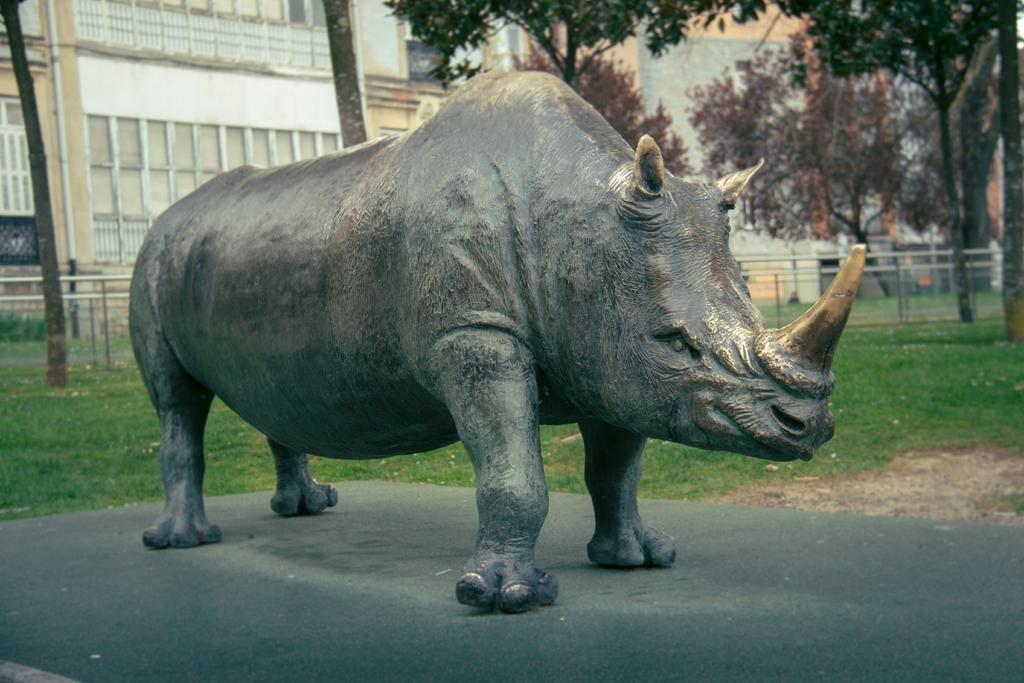What is the main subject of the image? There is a statue of a rhinoceros in the image. What else can be seen in the image besides the rhinoceros statue? There are buildings, trees, barricades, and grass in the image. What sound does the bell make in the image? There is no bell present in the image, so it is not possible to determine the sound it would make. 